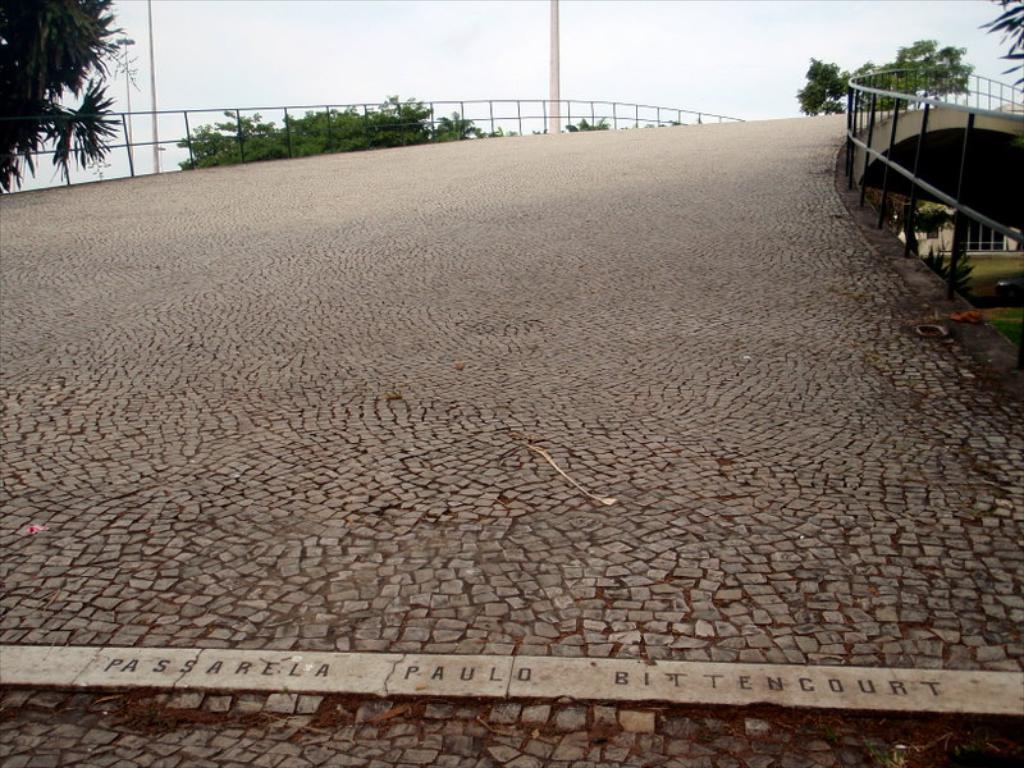What structure is present in the image? There is a bridge in the image. What can be seen near the bridge? There are trees to the side of the bridge. What feature is present on the bridge? There is a railing on the bridge. What else can be seen in the background of the image? There is a house and poles in the background of the image, as well as the sky. Can you see a tiger brushing its fur on the bridge in the image? There is no tiger or any other animal present in the image, and therefore no brushing activity can be observed. 